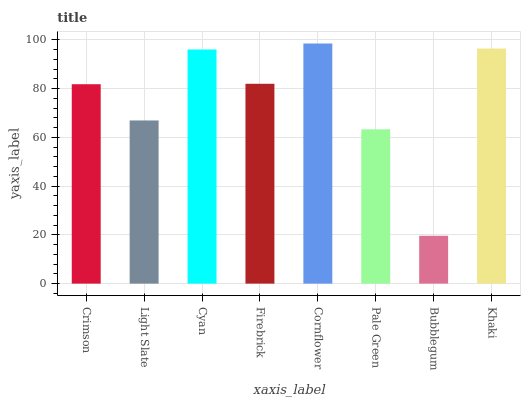Is Bubblegum the minimum?
Answer yes or no. Yes. Is Cornflower the maximum?
Answer yes or no. Yes. Is Light Slate the minimum?
Answer yes or no. No. Is Light Slate the maximum?
Answer yes or no. No. Is Crimson greater than Light Slate?
Answer yes or no. Yes. Is Light Slate less than Crimson?
Answer yes or no. Yes. Is Light Slate greater than Crimson?
Answer yes or no. No. Is Crimson less than Light Slate?
Answer yes or no. No. Is Firebrick the high median?
Answer yes or no. Yes. Is Crimson the low median?
Answer yes or no. Yes. Is Cornflower the high median?
Answer yes or no. No. Is Khaki the low median?
Answer yes or no. No. 